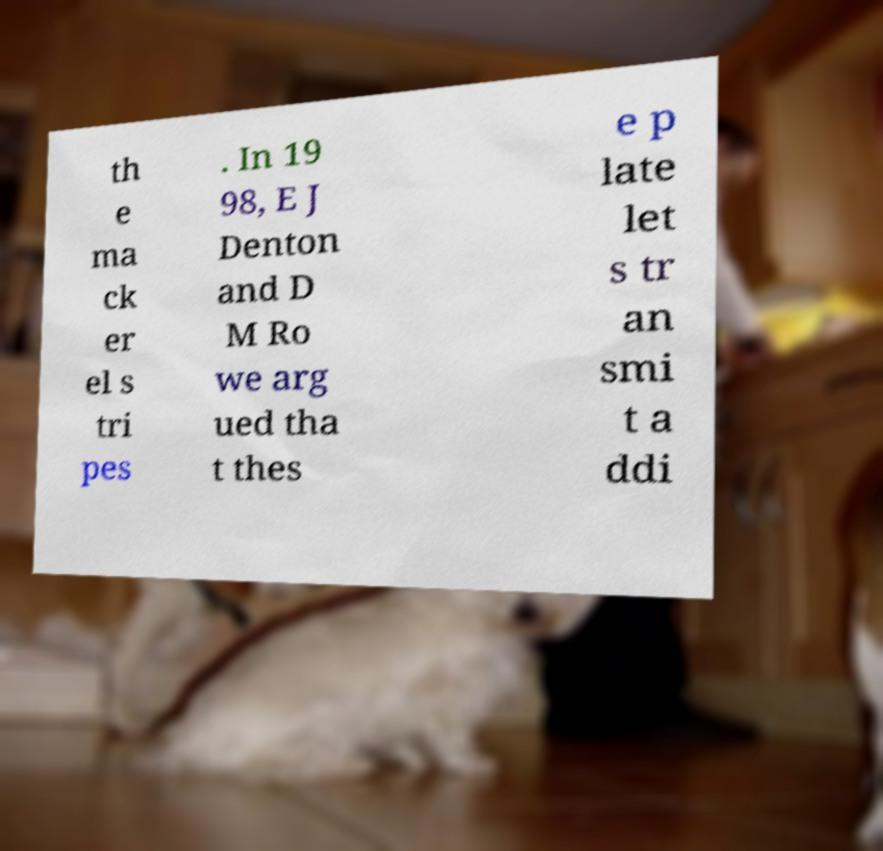What messages or text are displayed in this image? I need them in a readable, typed format. th e ma ck er el s tri pes . In 19 98, E J Denton and D M Ro we arg ued tha t thes e p late let s tr an smi t a ddi 